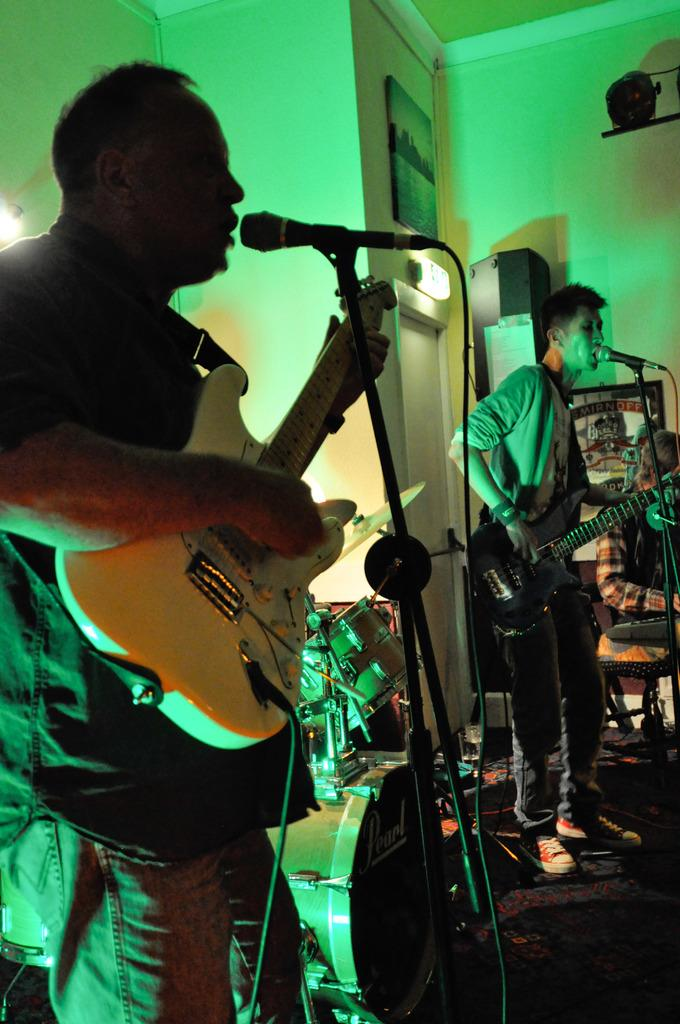How many people are in the image? There are two persons in the image. What are the two persons doing? They are playing guitar and singing. What can be seen in front of them? They are in front of a microphone. What other objects are present in the image? There are musical instruments in the image. Is there any artwork visible in the image? Yes, there is a picture on the wall. How does the steam from the guitar affect the sound in the image? There is no steam present in the image, and therefore it cannot affect the sound. 